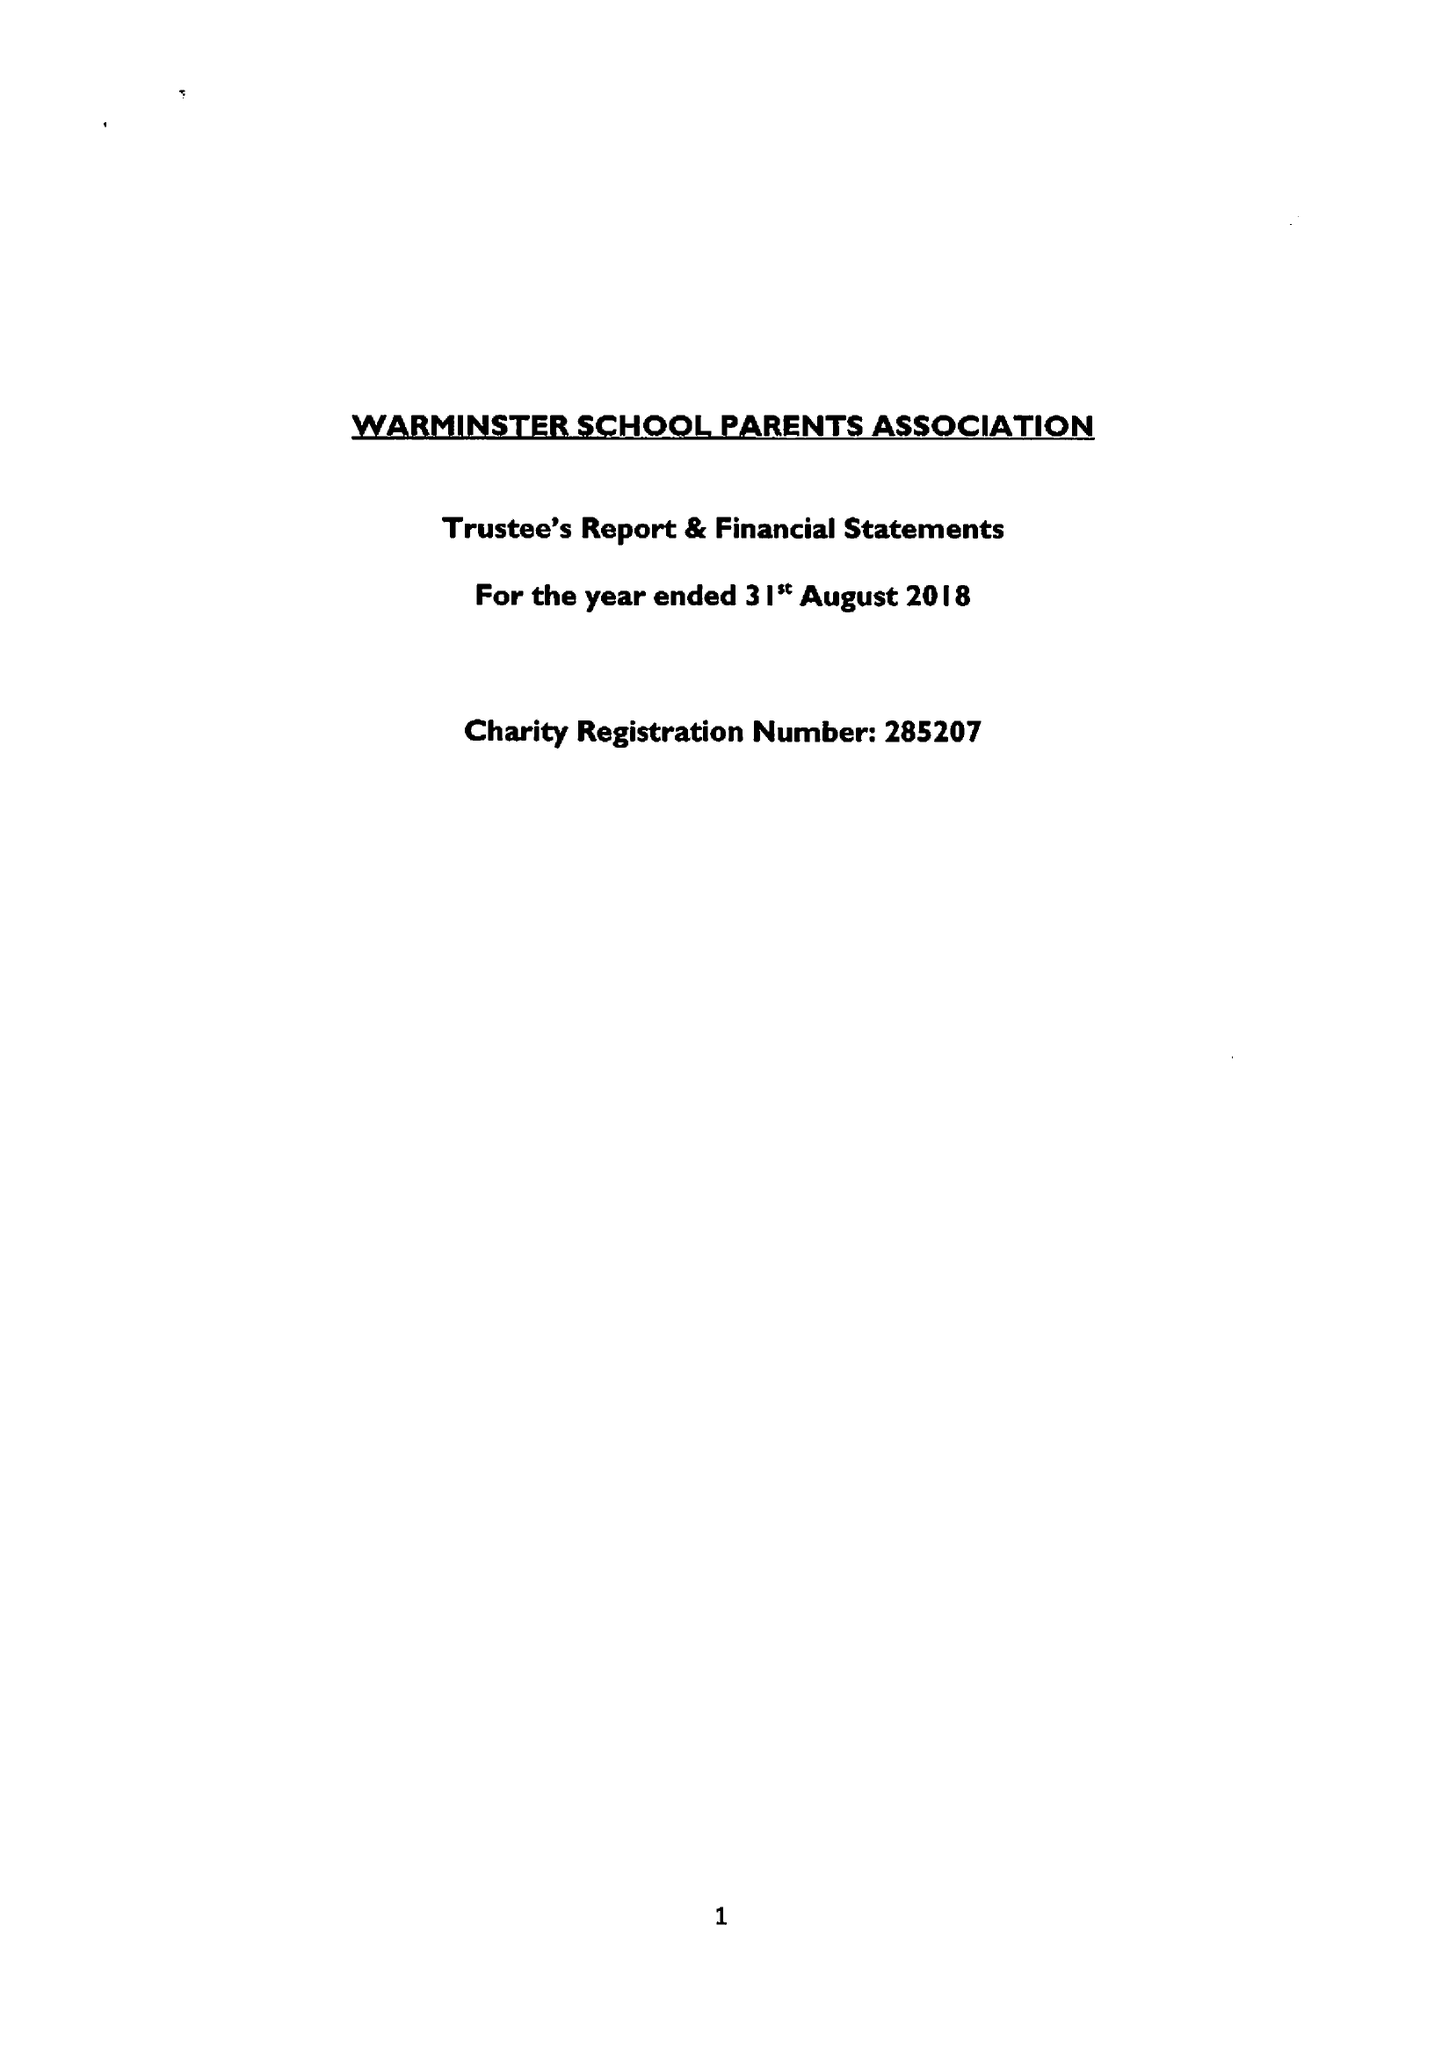What is the value for the income_annually_in_british_pounds?
Answer the question using a single word or phrase. 56030.00 